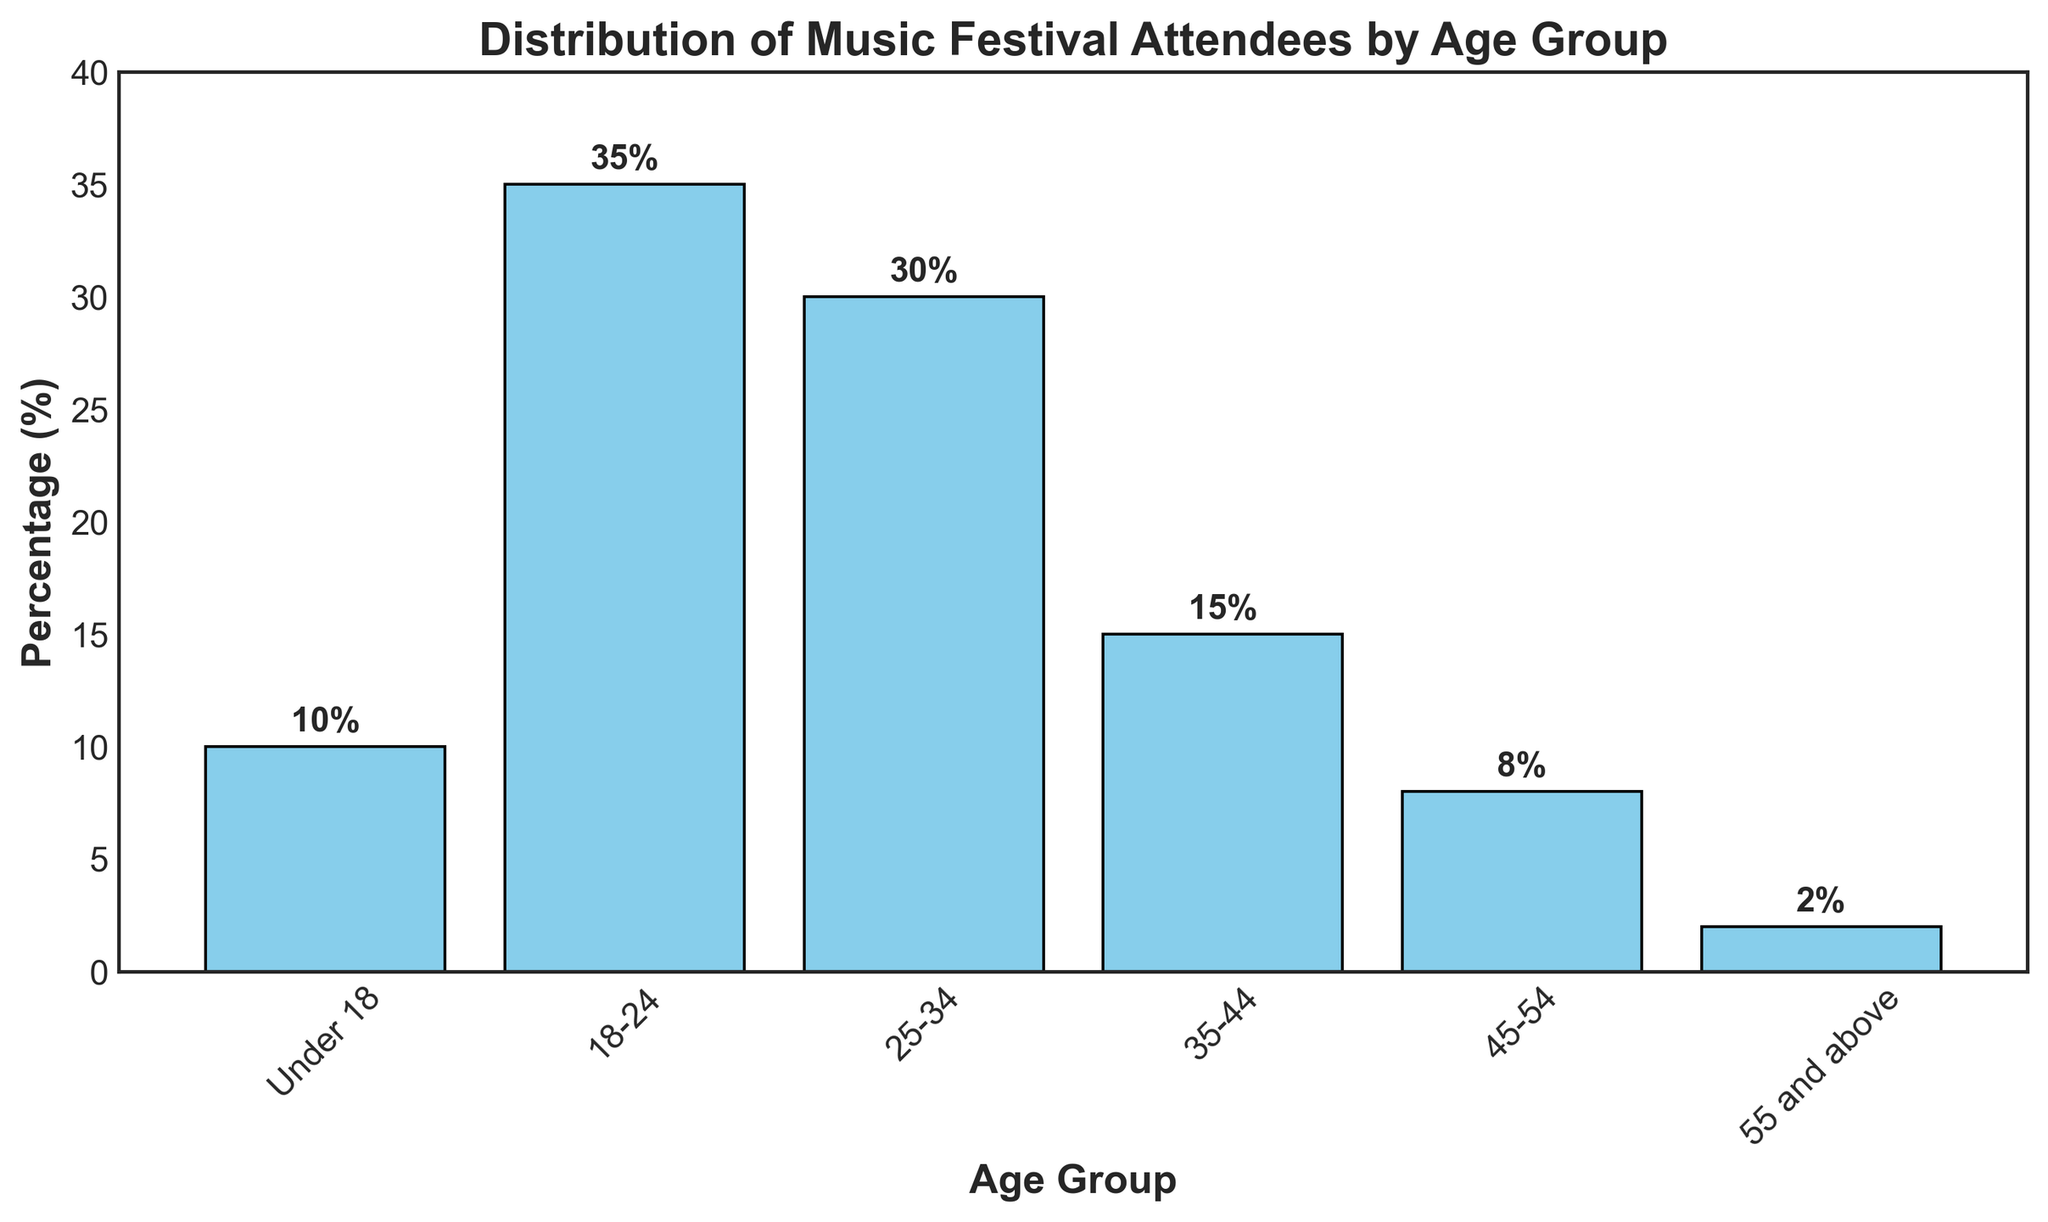Which age group has the highest percentage of music festival attendees? The bar representing the age group "18-24" is the highest, indicating this group has the highest percentage.
Answer: 18-24 What is the total percentage of attendees from the age groups under 18 and 18-24? To find the total percentage, add the percentages of these age groups: 10% (Under 18) + 35% (18-24). The total is 10 + 35 = 45%.
Answer: 45% Which age group has the lowest percentage of music festival attendees? The bar representing "55 and above" is the shortest, showing this group has the lowest percentage.
Answer: 55 and above How much more is the percentage of attendees in the 25-34 age group compared to the 45-54 age group? Subtract the percentage of the 45-54 group from the 25-34 group: 30% (25-34) - 8% (45-54). The difference is 30 - 8 = 22%.
Answer: 22% What percentage of attendees are aged 35-44? By referring to the bar labeled "35-44," you can see that its height corresponds to a percentage of 15%.
Answer: 15% What is the combined percentage of attendees aged 25-34 and 35-44? Add the percentages of these age groups: 30% (25-34) + 15% (35-44). The total is 30 + 15 = 45%.
Answer: 45% Which two age groups combined make up exactly 20% of the attendees? The "Under 18" group has 10%, and the "45-54" group has 8%. Adding these gives 10 + 8 = 18%, but adding "55 and above" 2% achieves 18% + 2% = 20%.
Answer: Under 18 and 55 and above By how much does the percentage of the 18-24 age group exceed the average percentage of all age groups? The average percentage is the sum of all percentages divided by the number of age groups: (10 + 35 + 30 + 15 + 8 + 2) / 6 = 100 / 6 ≈ 16.67%. The difference is: 35 - 16.67 ≈ 18.33%.
Answer: 18.33% Is the sum of the percentages for the "Under 18" and "35-44" groups greater than the percentage for the "18-24" group? Add the percentages for the "Under 18" and "35-44" groups: 10% + 15% = 25%. Compare this sum with 35% (18-24). 25% < 35%, so it is not greater.
Answer: No 